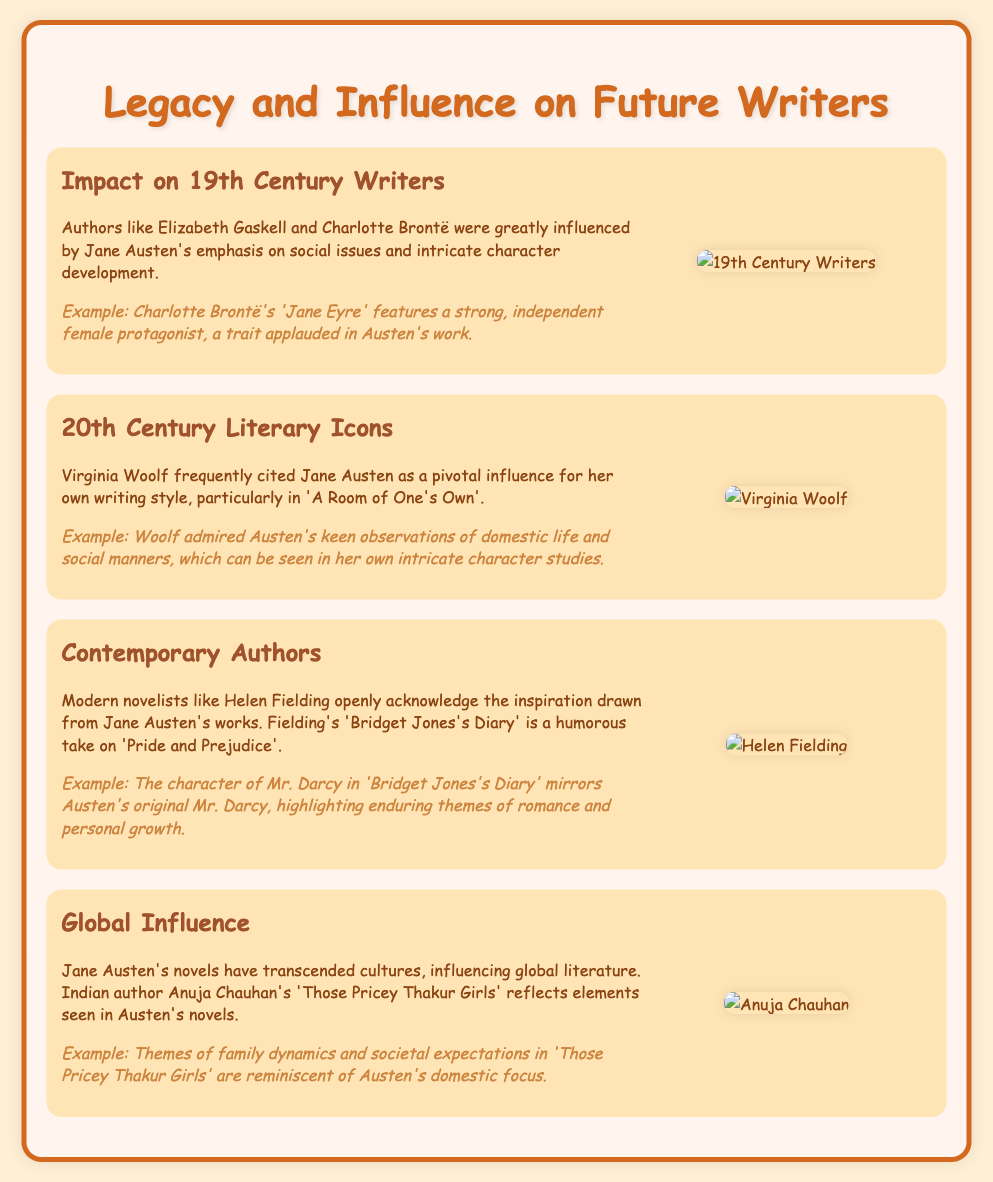What influence did Jane Austen have on 19th Century Writers? The slide mentions that authors like Elizabeth Gaskell and Charlotte Brontë were influenced by Austen's emphasis on social issues and character development.
Answer: Social issues and character development Which modern author is inspired by Jane Austen? The slide states that Helen Fielding draws inspiration from Austen's works, particularly in 'Bridget Jones's Diary'.
Answer: Helen Fielding What is a notable work of Charlotte Brontë mentioned? The document cites 'Jane Eyre' as a work influenced by Jane Austen.
Answer: Jane Eyre What element from Austen's work is reflected in Anuja Chauhan's novel? The slide notes that themes of family dynamics and societal expectations in Chauhan's novel are reminiscent of Austen's focus.
Answer: Family dynamics and societal expectations Which literary figure praised Jane Austen's observations of domestic life? Virginia Woolf is acknowledged as a writer who frequently cited Austen as a pivotal influence.
Answer: Virginia Woolf What is a key theme in both 'Pride and Prejudice' and 'Bridget Jones's Diary'? The slide highlights that themes of romance and personal growth are central to both works.
Answer: Romance and personal growth What is the relationship between Virginia Woolf and Jane Austen? Virginia Woolf cited Austen as a pivotal influence for her writing style, according to the document.
Answer: Pivotal influence Which 20th Century work is mentioned in relation to Jane Austen? 'A Room of One's Own' is highlighted as a work where Woolf cites Austen's influence.
Answer: A Room of One's Own What cultural influence is mentioned in relation to Jane Austen? The document states that Austen's novels have transcended cultures, influencing global literature.
Answer: Global literature 